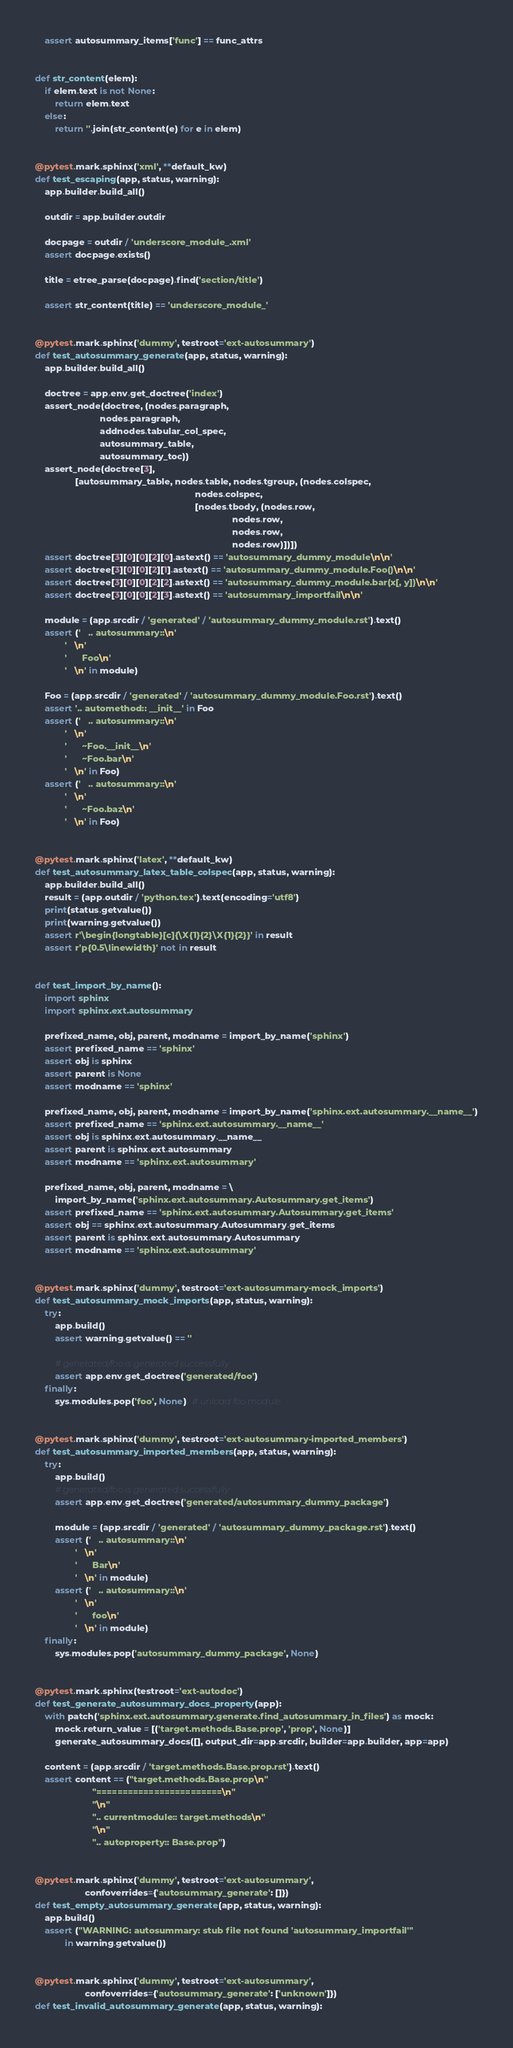<code> <loc_0><loc_0><loc_500><loc_500><_Python_>    assert autosummary_items['func'] == func_attrs


def str_content(elem):
    if elem.text is not None:
        return elem.text
    else:
        return ''.join(str_content(e) for e in elem)


@pytest.mark.sphinx('xml', **default_kw)
def test_escaping(app, status, warning):
    app.builder.build_all()

    outdir = app.builder.outdir

    docpage = outdir / 'underscore_module_.xml'
    assert docpage.exists()

    title = etree_parse(docpage).find('section/title')

    assert str_content(title) == 'underscore_module_'


@pytest.mark.sphinx('dummy', testroot='ext-autosummary')
def test_autosummary_generate(app, status, warning):
    app.builder.build_all()

    doctree = app.env.get_doctree('index')
    assert_node(doctree, (nodes.paragraph,
                          nodes.paragraph,
                          addnodes.tabular_col_spec,
                          autosummary_table,
                          autosummary_toc))
    assert_node(doctree[3],
                [autosummary_table, nodes.table, nodes.tgroup, (nodes.colspec,
                                                                nodes.colspec,
                                                                [nodes.tbody, (nodes.row,
                                                                               nodes.row,
                                                                               nodes.row,
                                                                               nodes.row)])])
    assert doctree[3][0][0][2][0].astext() == 'autosummary_dummy_module\n\n'
    assert doctree[3][0][0][2][1].astext() == 'autosummary_dummy_module.Foo()\n\n'
    assert doctree[3][0][0][2][2].astext() == 'autosummary_dummy_module.bar(x[, y])\n\n'
    assert doctree[3][0][0][2][3].astext() == 'autosummary_importfail\n\n'

    module = (app.srcdir / 'generated' / 'autosummary_dummy_module.rst').text()
    assert ('   .. autosummary::\n'
            '   \n'
            '      Foo\n'
            '   \n' in module)

    Foo = (app.srcdir / 'generated' / 'autosummary_dummy_module.Foo.rst').text()
    assert '.. automethod:: __init__' in Foo
    assert ('   .. autosummary::\n'
            '   \n'
            '      ~Foo.__init__\n'
            '      ~Foo.bar\n'
            '   \n' in Foo)
    assert ('   .. autosummary::\n'
            '   \n'
            '      ~Foo.baz\n'
            '   \n' in Foo)


@pytest.mark.sphinx('latex', **default_kw)
def test_autosummary_latex_table_colspec(app, status, warning):
    app.builder.build_all()
    result = (app.outdir / 'python.tex').text(encoding='utf8')
    print(status.getvalue())
    print(warning.getvalue())
    assert r'\begin{longtable}[c]{\X{1}{2}\X{1}{2}}' in result
    assert r'p{0.5\linewidth}' not in result


def test_import_by_name():
    import sphinx
    import sphinx.ext.autosummary

    prefixed_name, obj, parent, modname = import_by_name('sphinx')
    assert prefixed_name == 'sphinx'
    assert obj is sphinx
    assert parent is None
    assert modname == 'sphinx'

    prefixed_name, obj, parent, modname = import_by_name('sphinx.ext.autosummary.__name__')
    assert prefixed_name == 'sphinx.ext.autosummary.__name__'
    assert obj is sphinx.ext.autosummary.__name__
    assert parent is sphinx.ext.autosummary
    assert modname == 'sphinx.ext.autosummary'

    prefixed_name, obj, parent, modname = \
        import_by_name('sphinx.ext.autosummary.Autosummary.get_items')
    assert prefixed_name == 'sphinx.ext.autosummary.Autosummary.get_items'
    assert obj == sphinx.ext.autosummary.Autosummary.get_items
    assert parent is sphinx.ext.autosummary.Autosummary
    assert modname == 'sphinx.ext.autosummary'


@pytest.mark.sphinx('dummy', testroot='ext-autosummary-mock_imports')
def test_autosummary_mock_imports(app, status, warning):
    try:
        app.build()
        assert warning.getvalue() == ''

        # generated/foo is generated successfully
        assert app.env.get_doctree('generated/foo')
    finally:
        sys.modules.pop('foo', None)  # unload foo module


@pytest.mark.sphinx('dummy', testroot='ext-autosummary-imported_members')
def test_autosummary_imported_members(app, status, warning):
    try:
        app.build()
        # generated/foo is generated successfully
        assert app.env.get_doctree('generated/autosummary_dummy_package')

        module = (app.srcdir / 'generated' / 'autosummary_dummy_package.rst').text()
        assert ('   .. autosummary::\n'
                '   \n'
                '      Bar\n'
                '   \n' in module)
        assert ('   .. autosummary::\n'
                '   \n'
                '      foo\n'
                '   \n' in module)
    finally:
        sys.modules.pop('autosummary_dummy_package', None)


@pytest.mark.sphinx(testroot='ext-autodoc')
def test_generate_autosummary_docs_property(app):
    with patch('sphinx.ext.autosummary.generate.find_autosummary_in_files') as mock:
        mock.return_value = [('target.methods.Base.prop', 'prop', None)]
        generate_autosummary_docs([], output_dir=app.srcdir, builder=app.builder, app=app)

    content = (app.srcdir / 'target.methods.Base.prop.rst').text()
    assert content == ("target.methods.Base.prop\n"
                       "========================\n"
                       "\n"
                       ".. currentmodule:: target.methods\n"
                       "\n"
                       ".. autoproperty:: Base.prop")


@pytest.mark.sphinx('dummy', testroot='ext-autosummary',
                    confoverrides={'autosummary_generate': []})
def test_empty_autosummary_generate(app, status, warning):
    app.build()
    assert ("WARNING: autosummary: stub file not found 'autosummary_importfail'"
            in warning.getvalue())


@pytest.mark.sphinx('dummy', testroot='ext-autosummary',
                    confoverrides={'autosummary_generate': ['unknown']})
def test_invalid_autosummary_generate(app, status, warning):</code> 